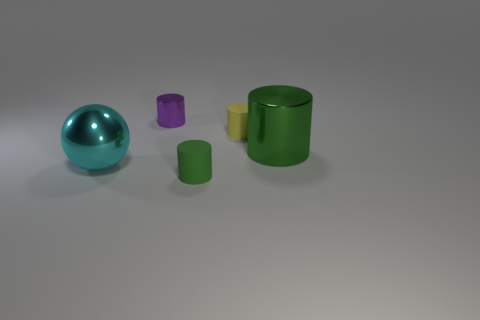Subtract all tiny purple cylinders. How many cylinders are left? 3 Subtract all brown cylinders. Subtract all cyan balls. How many cylinders are left? 4 Add 1 gray things. How many objects exist? 6 Subtract all cylinders. How many objects are left? 1 Subtract all small purple metal cylinders. Subtract all tiny purple shiny cylinders. How many objects are left? 3 Add 3 small yellow cylinders. How many small yellow cylinders are left? 4 Add 2 big metallic things. How many big metallic things exist? 4 Subtract 1 green cylinders. How many objects are left? 4 